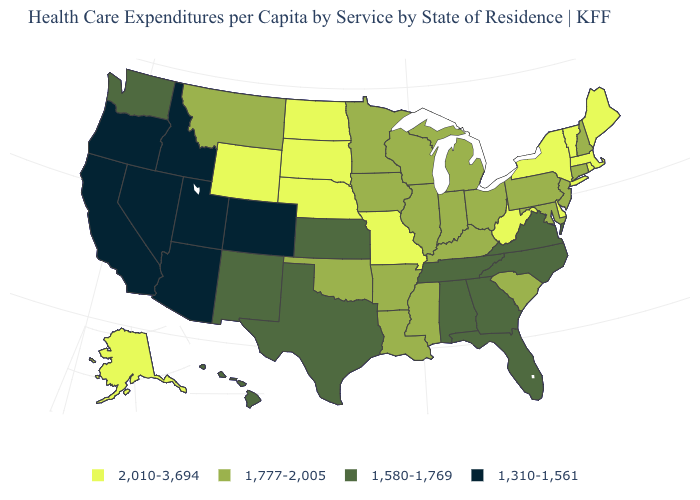What is the value of New Mexico?
Give a very brief answer. 1,580-1,769. What is the value of Maryland?
Keep it brief. 1,777-2,005. Does New Jersey have the same value as Tennessee?
Write a very short answer. No. Does Delaware have a higher value than Maryland?
Quick response, please. Yes. What is the value of Iowa?
Concise answer only. 1,777-2,005. How many symbols are there in the legend?
Give a very brief answer. 4. Is the legend a continuous bar?
Write a very short answer. No. Name the states that have a value in the range 1,580-1,769?
Short answer required. Alabama, Florida, Georgia, Hawaii, Kansas, New Mexico, North Carolina, Tennessee, Texas, Virginia, Washington. Which states have the lowest value in the West?
Answer briefly. Arizona, California, Colorado, Idaho, Nevada, Oregon, Utah. Name the states that have a value in the range 1,777-2,005?
Give a very brief answer. Arkansas, Connecticut, Illinois, Indiana, Iowa, Kentucky, Louisiana, Maryland, Michigan, Minnesota, Mississippi, Montana, New Hampshire, New Jersey, Ohio, Oklahoma, Pennsylvania, South Carolina, Wisconsin. What is the value of Wyoming?
Short answer required. 2,010-3,694. Which states hav the highest value in the West?
Keep it brief. Alaska, Wyoming. Is the legend a continuous bar?
Be succinct. No. What is the highest value in the USA?
Quick response, please. 2,010-3,694. Name the states that have a value in the range 1,777-2,005?
Write a very short answer. Arkansas, Connecticut, Illinois, Indiana, Iowa, Kentucky, Louisiana, Maryland, Michigan, Minnesota, Mississippi, Montana, New Hampshire, New Jersey, Ohio, Oklahoma, Pennsylvania, South Carolina, Wisconsin. 